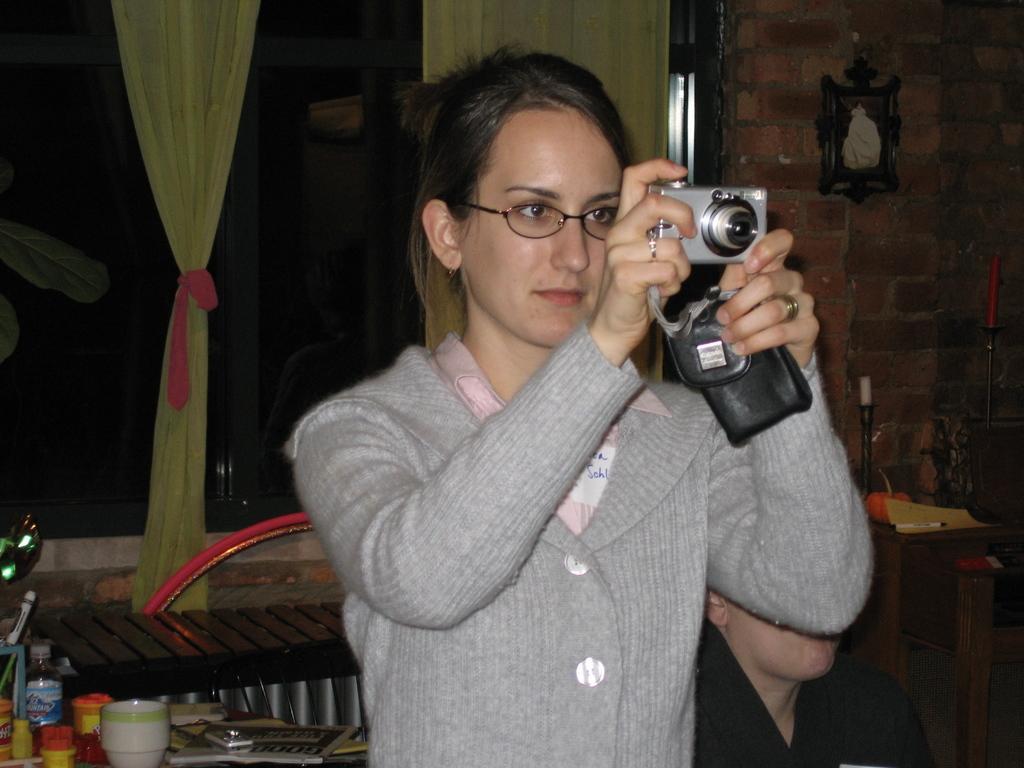How would you summarize this image in a sentence or two? In this image we can see a woman capturing an image with a camera. She is wearing a sweater. Here we can see a man on the bottom right side. Here we can see the wooden table. Here we can see a bowl and a water bottle on the table. Here we can see another wooden table on the right side. In the background, we can see the glass windows and here we can see the curtains. 